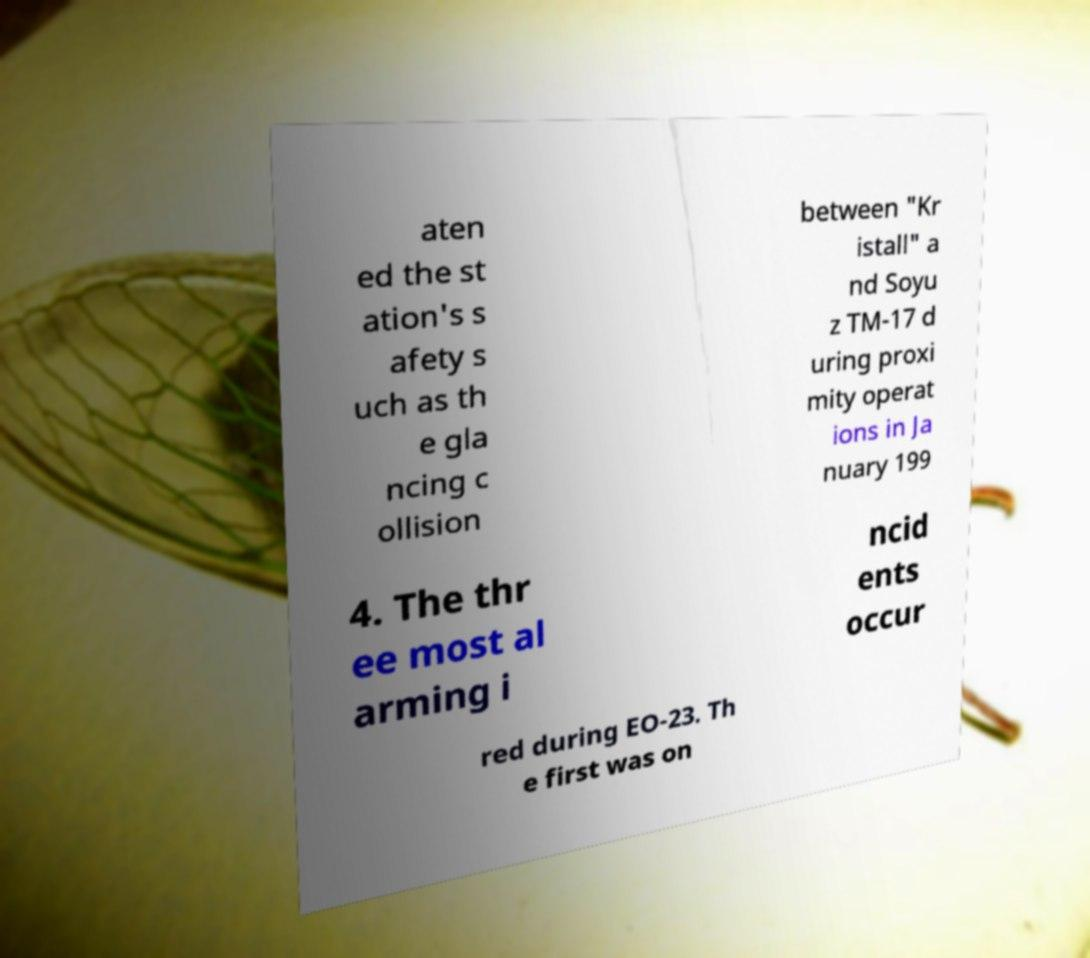Please read and relay the text visible in this image. What does it say? aten ed the st ation's s afety s uch as th e gla ncing c ollision between "Kr istall" a nd Soyu z TM-17 d uring proxi mity operat ions in Ja nuary 199 4. The thr ee most al arming i ncid ents occur red during EO-23. Th e first was on 